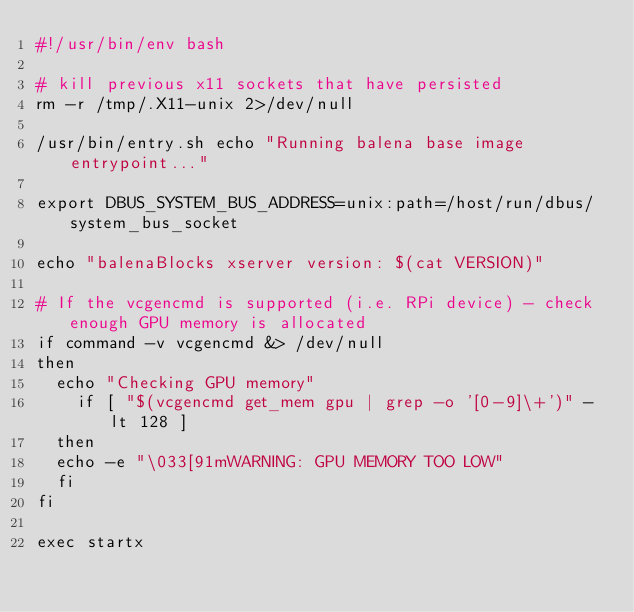<code> <loc_0><loc_0><loc_500><loc_500><_Bash_>#!/usr/bin/env bash

# kill previous x11 sockets that have persisted
rm -r /tmp/.X11-unix 2>/dev/null

/usr/bin/entry.sh echo "Running balena base image entrypoint..."

export DBUS_SYSTEM_BUS_ADDRESS=unix:path=/host/run/dbus/system_bus_socket

echo "balenaBlocks xserver version: $(cat VERSION)"

# If the vcgencmd is supported (i.e. RPi device) - check enough GPU memory is allocated
if command -v vcgencmd &> /dev/null
then
	echo "Checking GPU memory"
    if [ "$(vcgencmd get_mem gpu | grep -o '[0-9]\+')" -lt 128 ]
	then
	echo -e "\033[91mWARNING: GPU MEMORY TOO LOW"
	fi
fi

exec startx
</code> 